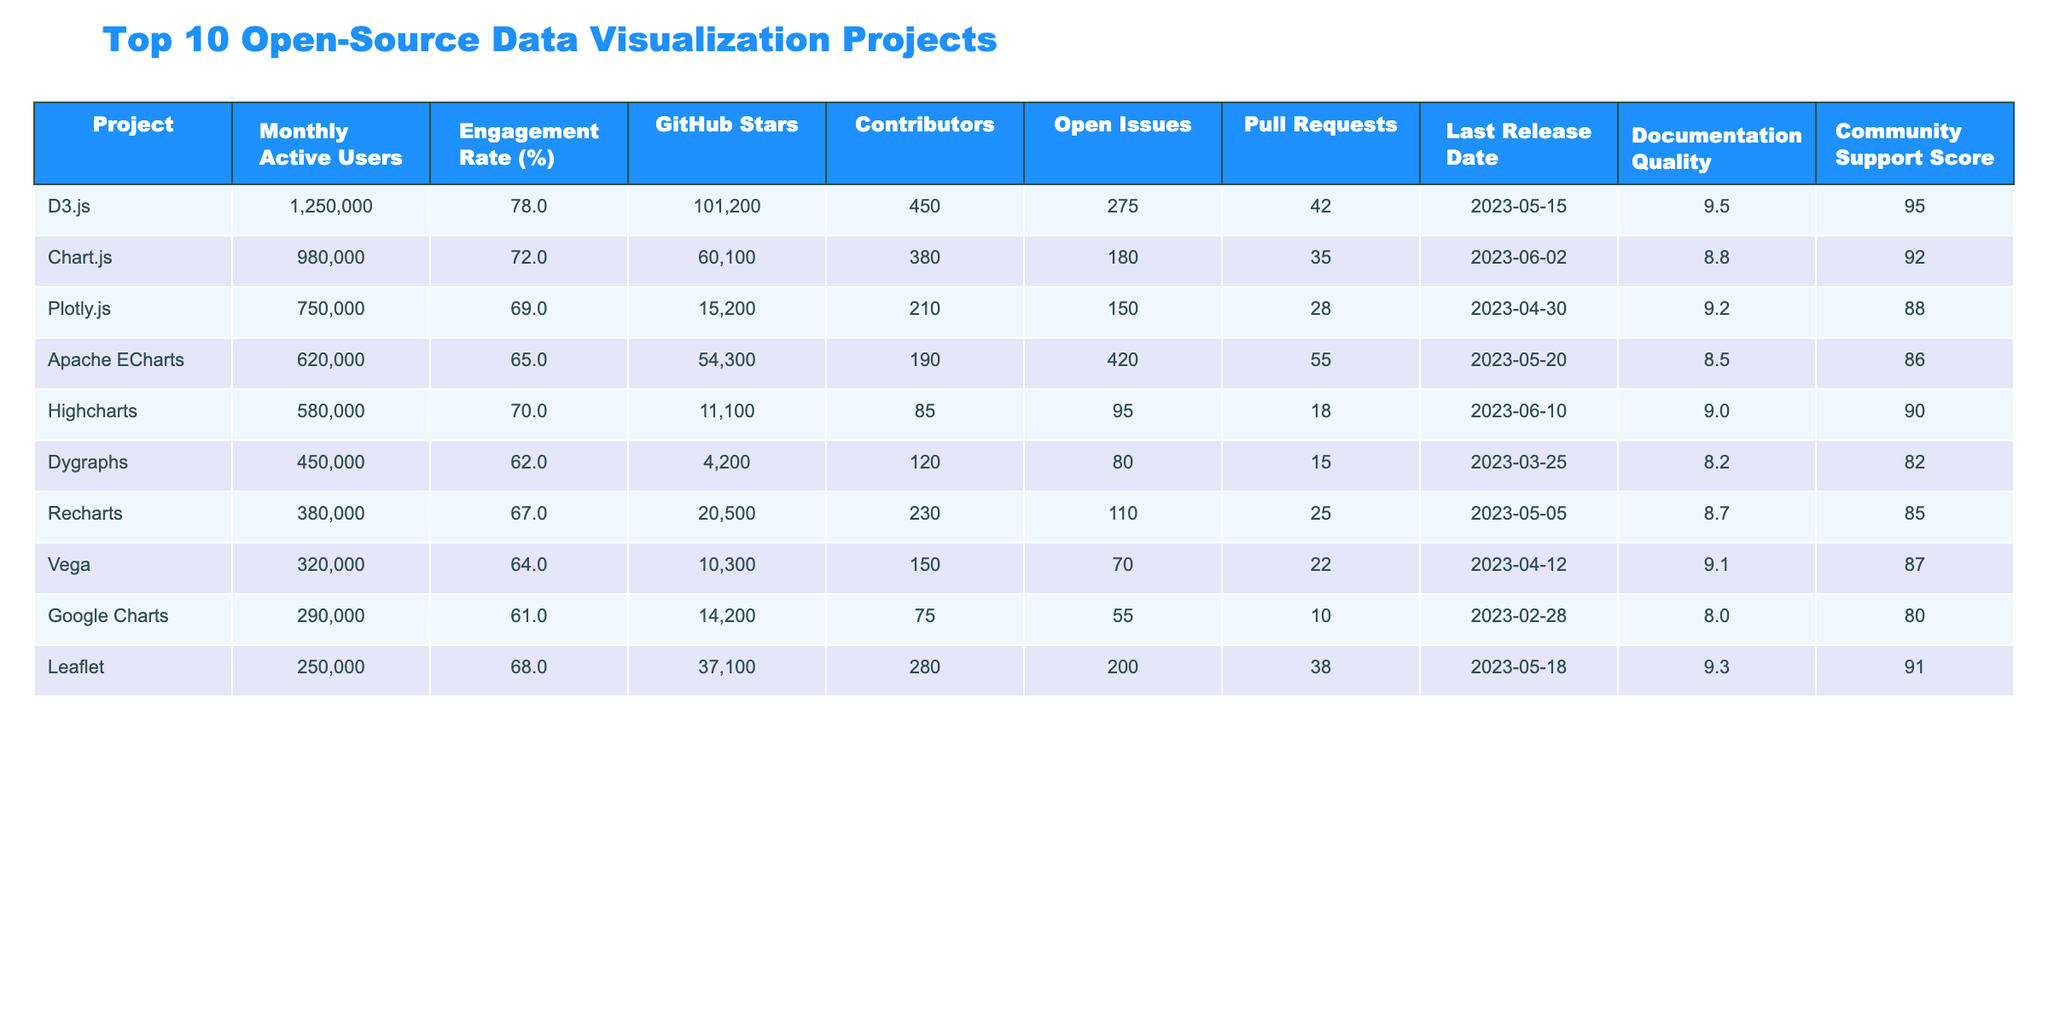What is the Monthly Active Users for D3.js? The table lists D3.js under the Project column, and its corresponding Monthly Active Users is stated as 1,250,000.
Answer: 1,250,000 What is the Engagement Rate for Chart.js? The Engagement Rate for Chart.js can be found in the Engagement Rate (%) column next to Chart.js, which is 72%.
Answer: 72% Which project has the highest number of GitHub Stars? By examining the GitHub Stars column, D3.js has the highest value at 101,200 stars compared to the others.
Answer: D3.js How many Contributors does Highcharts have? The number of contributors for Highcharts can be found in the Contributors column next to its name, which is 85.
Answer: 85 What is the difference in Engagement Rates between Leaflet and Dygraphs? Leaflet has an engagement rate of 68% and Dygraphs has 62%. The difference is calculated as 68% - 62% = 6%.
Answer: 6% What is the average number of Open Issues for all projects listed? To find the average, sum the Open Issues (275 + 180 + 150 + 420 + 95 + 80 + 110 + 70 + 55 + 200 = 1665) and divide by the number of projects (10), resulting in an average of 166.5.
Answer: 166.5 Does any project have more than 1 million Monthly Active Users? Upon reviewing the Monthly Active Users column, only D3.js exceeds 1 million, making the statement true.
Answer: Yes Which project has the lowest Engagement Rate? In the Engagement Rate (%) column, Dygraphs is shown as having the lowest rate of 62%, making it the answer to the question.
Answer: Dygraphs What is the total number of GitHub Stars for all projects combined? By summing the GitHub Stars (101200 + 60100 + 15200 + 54300 + 11100 + 4200 + 20500 + 10300 + 14200 + 37100 = 402,100), the total comes to 402,100 stars across all projects.
Answer: 402,100 Which project has the longest time since its Last Release? Evaluating the Last Release Date of each project reveals that Google Charts, with a release date of 2023-02-28, has the earliest date, hence the longest time since release.
Answer: Google Charts 